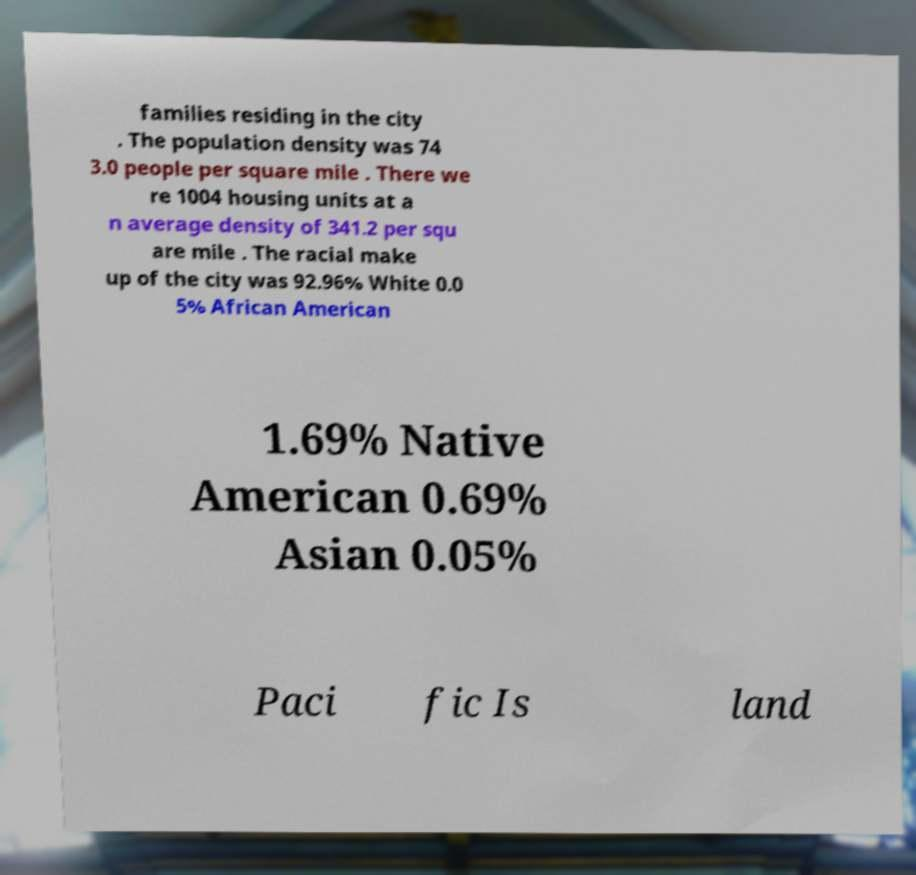There's text embedded in this image that I need extracted. Can you transcribe it verbatim? families residing in the city . The population density was 74 3.0 people per square mile . There we re 1004 housing units at a n average density of 341.2 per squ are mile . The racial make up of the city was 92.96% White 0.0 5% African American 1.69% Native American 0.69% Asian 0.05% Paci fic Is land 